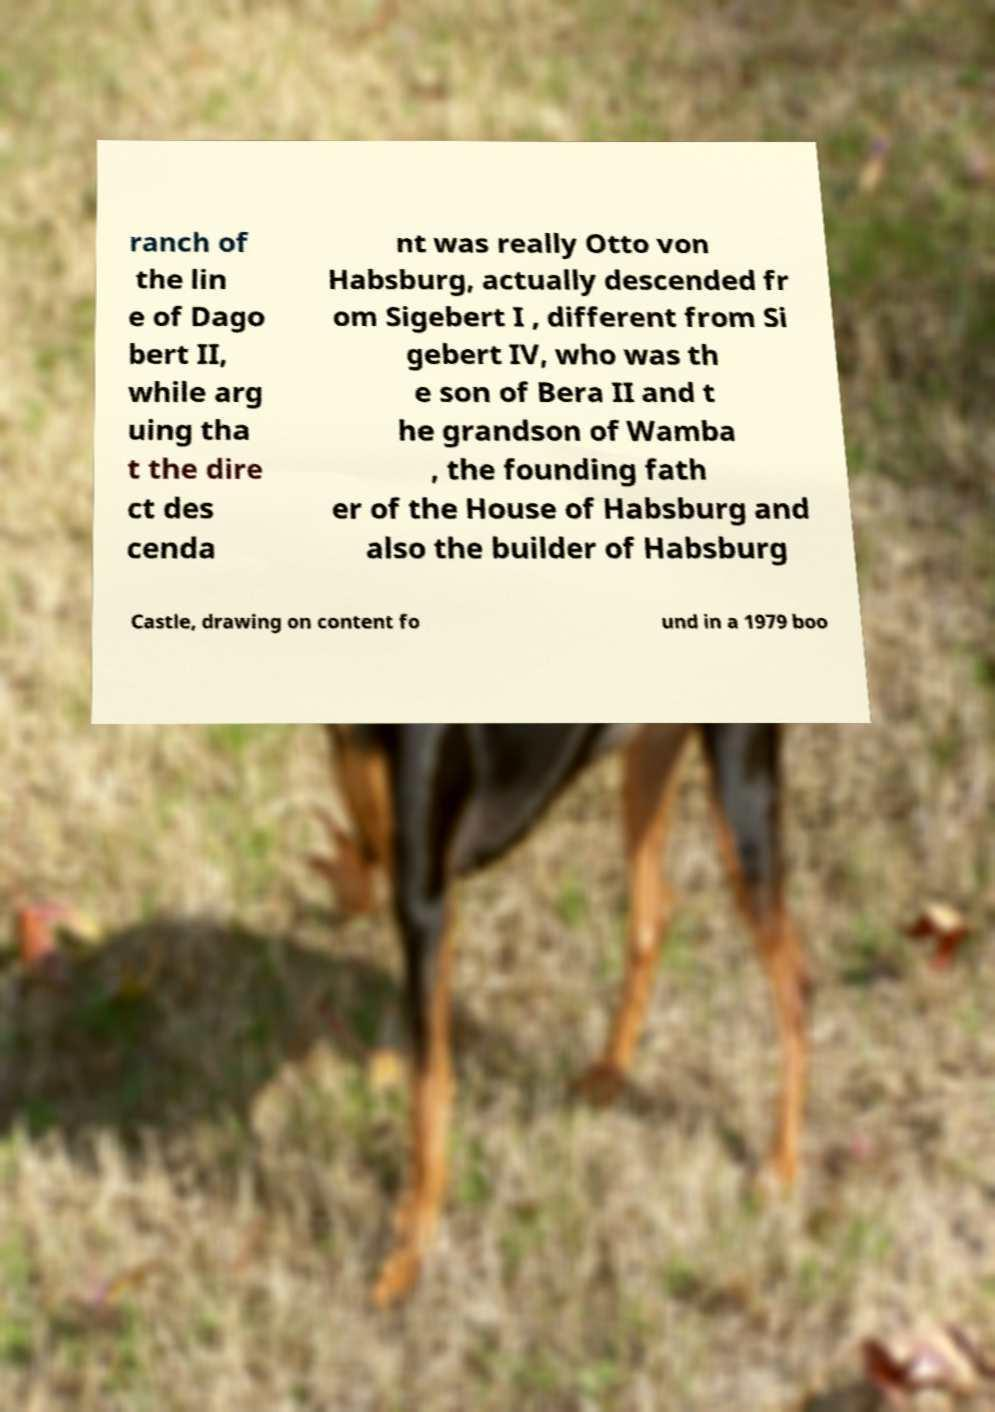Could you assist in decoding the text presented in this image and type it out clearly? ranch of the lin e of Dago bert II, while arg uing tha t the dire ct des cenda nt was really Otto von Habsburg, actually descended fr om Sigebert I , different from Si gebert IV, who was th e son of Bera II and t he grandson of Wamba , the founding fath er of the House of Habsburg and also the builder of Habsburg Castle, drawing on content fo und in a 1979 boo 